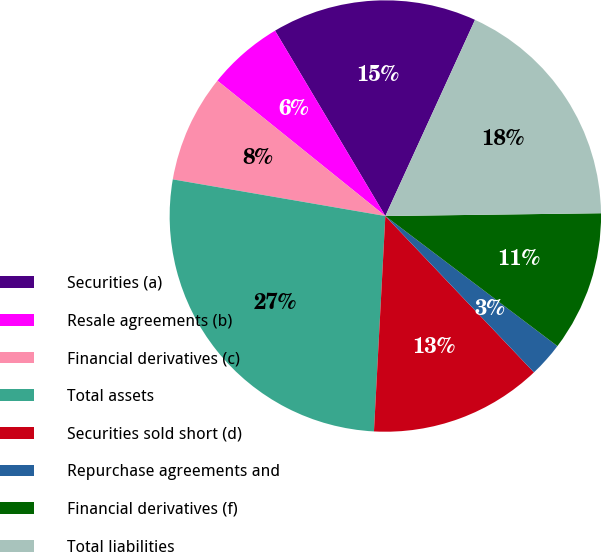Convert chart. <chart><loc_0><loc_0><loc_500><loc_500><pie_chart><fcel>Securities (a)<fcel>Resale agreements (b)<fcel>Financial derivatives (c)<fcel>Total assets<fcel>Securities sold short (d)<fcel>Repurchase agreements and<fcel>Financial derivatives (f)<fcel>Total liabilities<nl><fcel>15.37%<fcel>5.66%<fcel>8.08%<fcel>26.88%<fcel>12.94%<fcel>2.6%<fcel>10.51%<fcel>17.97%<nl></chart> 